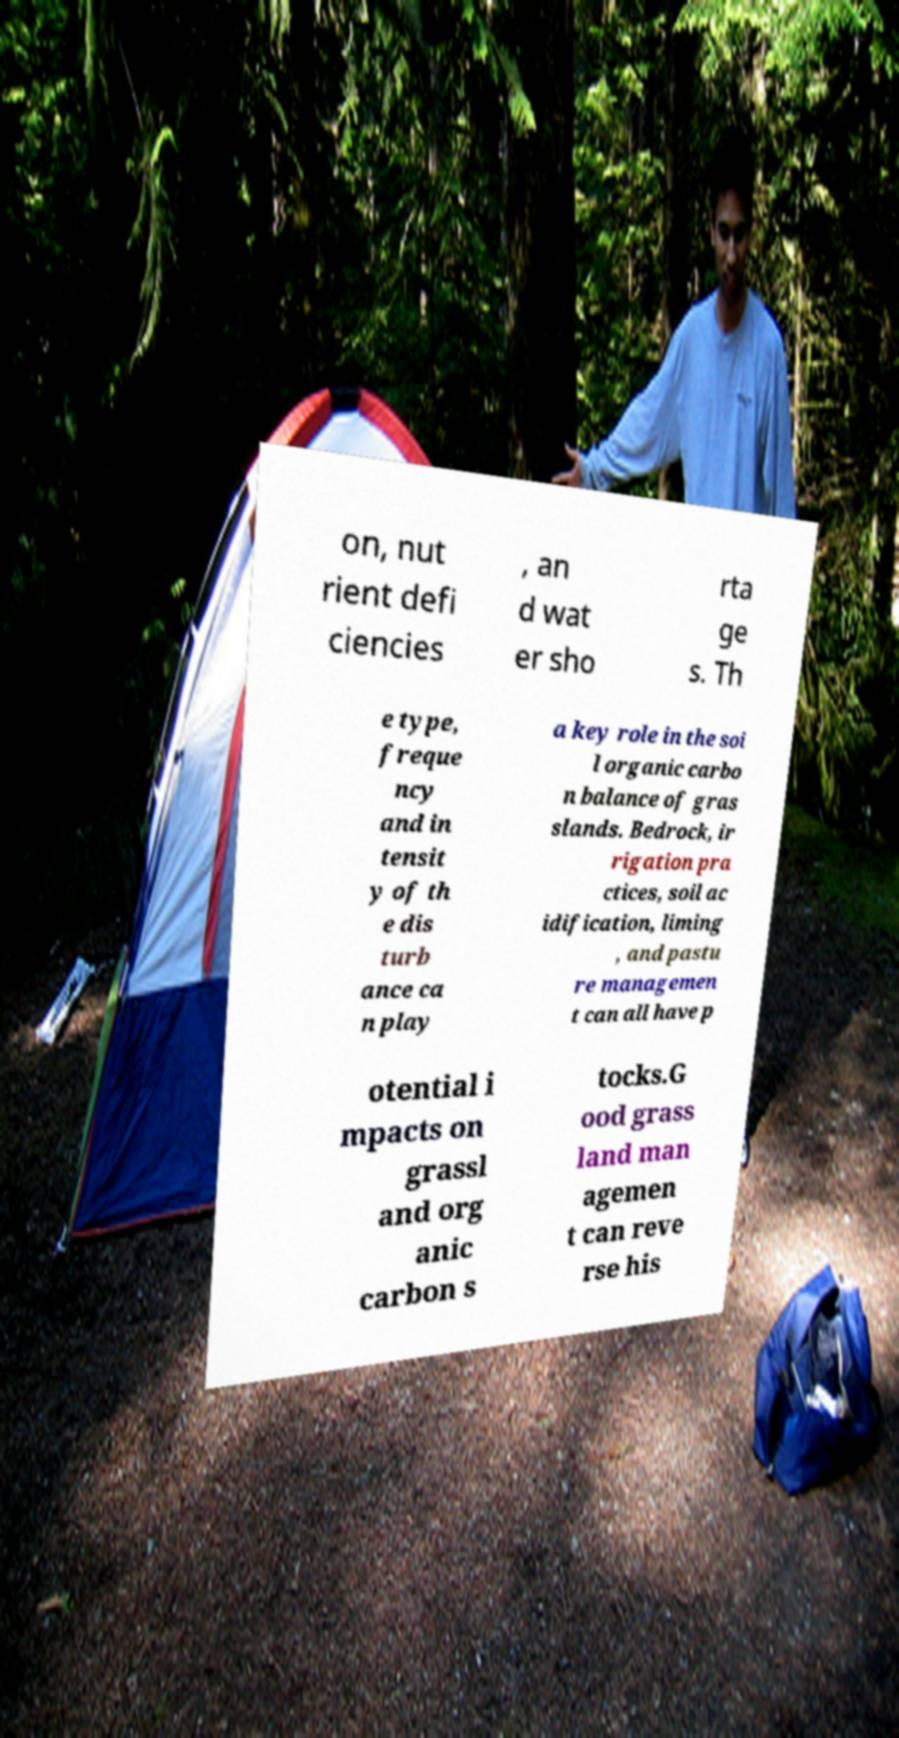There's text embedded in this image that I need extracted. Can you transcribe it verbatim? on, nut rient defi ciencies , an d wat er sho rta ge s. Th e type, freque ncy and in tensit y of th e dis turb ance ca n play a key role in the soi l organic carbo n balance of gras slands. Bedrock, ir rigation pra ctices, soil ac idification, liming , and pastu re managemen t can all have p otential i mpacts on grassl and org anic carbon s tocks.G ood grass land man agemen t can reve rse his 